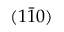Convert formula to latex. <formula><loc_0><loc_0><loc_500><loc_500>( 1 \bar { 1 } 0 )</formula> 